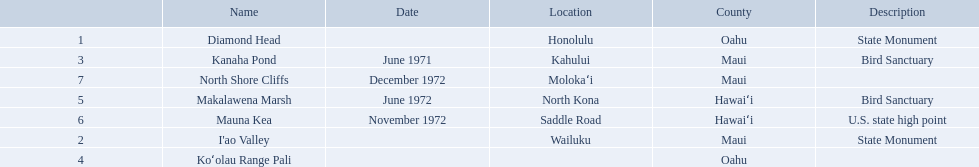What are all of the landmark names? Diamond Head, I'ao Valley, Kanaha Pond, Koʻolau Range Pali, Makalawena Marsh, Mauna Kea, North Shore Cliffs. Where are they located? Honolulu, Wailuku, Kahului, , North Kona, Saddle Road, Molokaʻi. And which landmark has no listed location? Koʻolau Range Pali. 